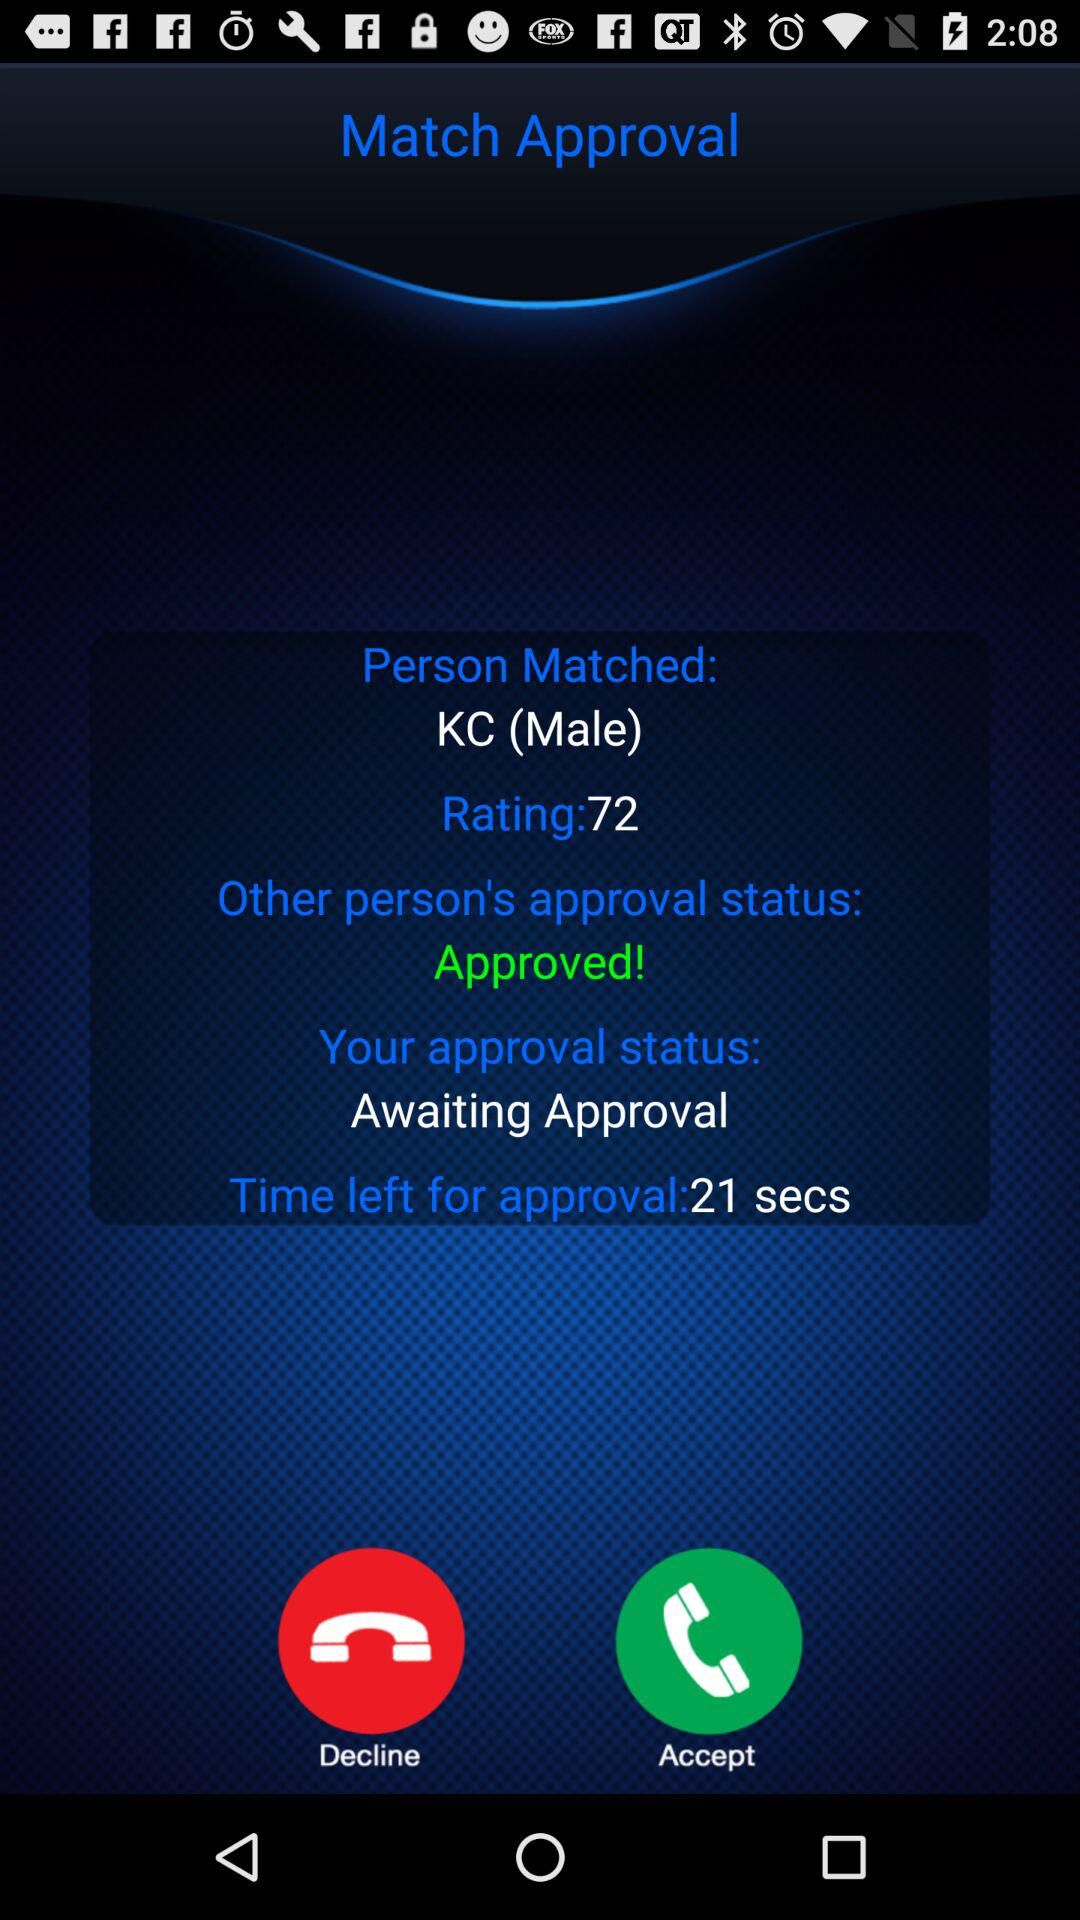What is the name of the matched person? The name of the person is KC. 